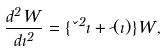Convert formula to latex. <formula><loc_0><loc_0><loc_500><loc_500>\frac { d ^ { 2 } W } { d \zeta ^ { 2 } } = \{ \kappa ^ { 2 } \zeta + \psi ( \zeta ) \} W ,</formula> 